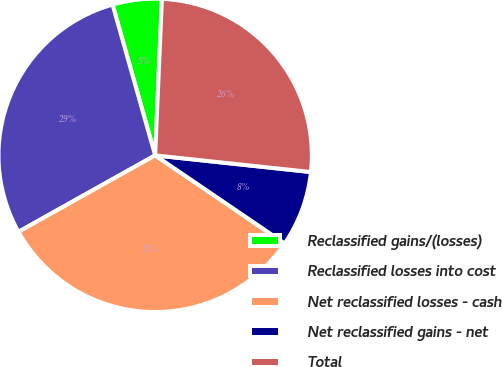Convert chart to OTSL. <chart><loc_0><loc_0><loc_500><loc_500><pie_chart><fcel>Reclassified gains/(losses)<fcel>Reclassified losses into cost<fcel>Net reclassified losses - cash<fcel>Net reclassified gains - net<fcel>Total<nl><fcel>5.07%<fcel>28.74%<fcel>32.38%<fcel>7.81%<fcel>26.01%<nl></chart> 